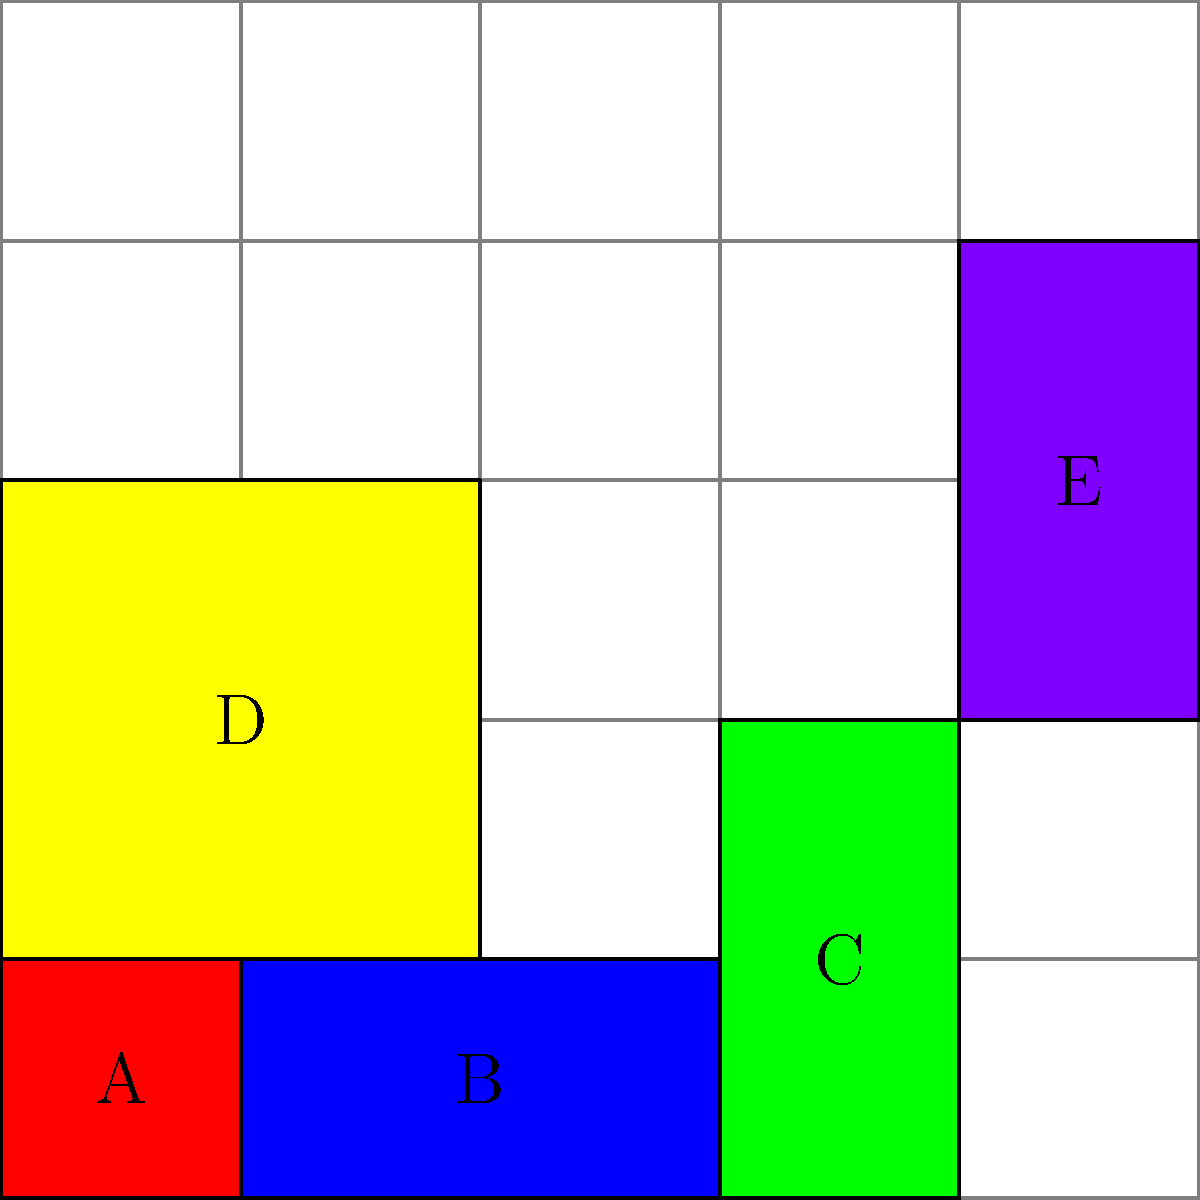In the given 5x5 grid representing a storage area for rescue equipment, five items (A, B, C, D, and E) are arranged. What is the total area occupied by equipment B and D combined? To solve this problem, we need to follow these steps:

1. Identify the equipment B and D in the grid:
   - Equipment B is the blue rectangle at the bottom
   - Equipment D is the yellow rectangle on the left side

2. Calculate the area of equipment B:
   - B occupies 2 units in width and 1 unit in height
   - Area of B = $2 \times 1 = 2$ square units

3. Calculate the area of equipment D:
   - D occupies 2 units in width and 2 units in height
   - Area of D = $2 \times 2 = 4$ square units

4. Sum up the areas of B and D:
   - Total area = Area of B + Area of D
   - Total area = $2 + 4 = 6$ square units

Therefore, the total area occupied by equipment B and D combined is 6 square units.
Answer: 6 square units 